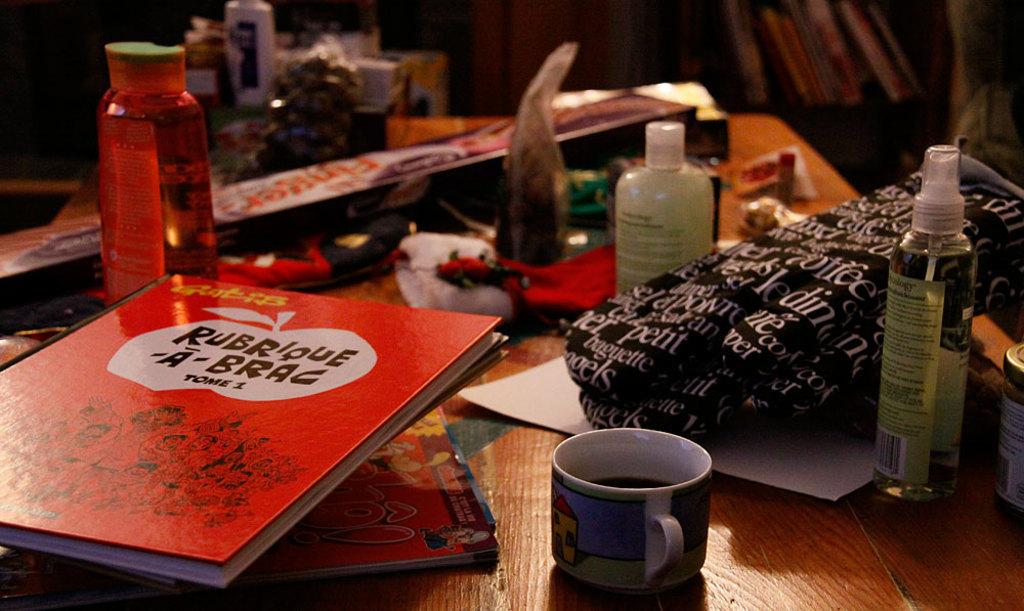What is the title of the book?
Your response must be concise. Rubrique a brag. 